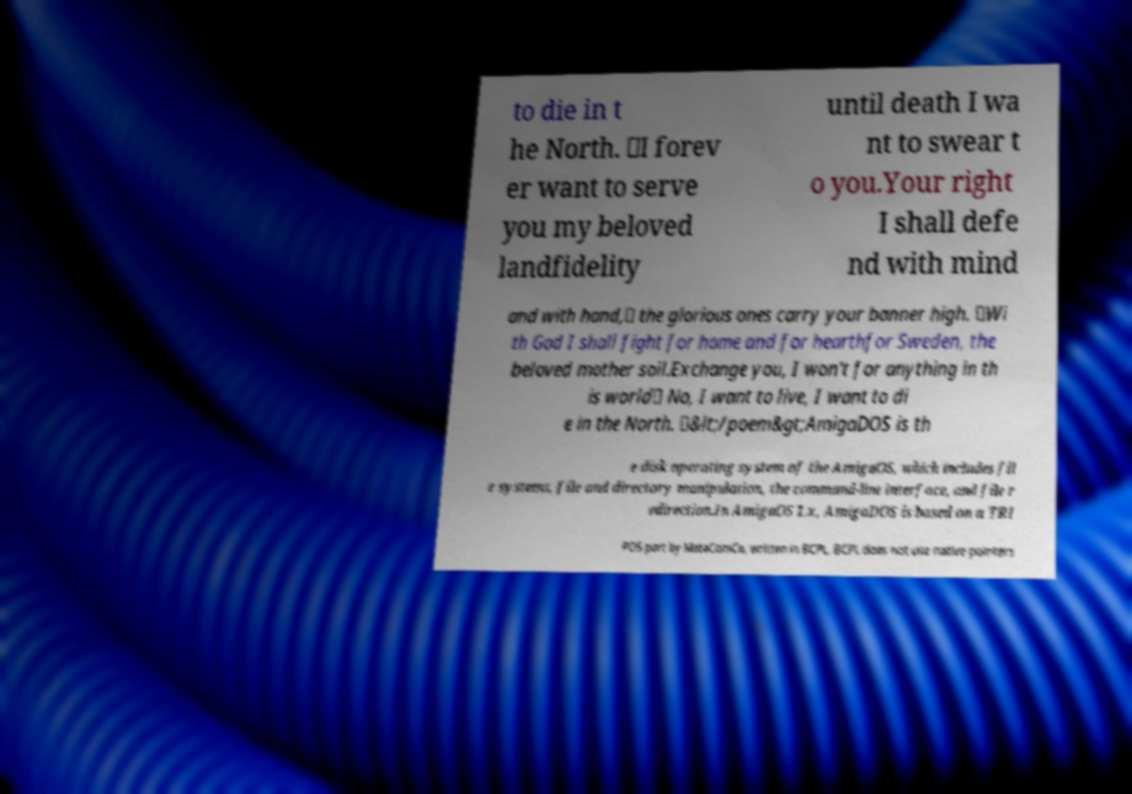There's text embedded in this image that I need extracted. Can you transcribe it verbatim? to die in t he North. 𝄇I forev er want to serve you my beloved landfidelity until death I wa nt to swear t o you.Your right I shall defe nd with mind and with hand,𝄆 the glorious ones carry your banner high. 𝄇Wi th God I shall fight for home and for hearthfor Sweden, the beloved mother soil.Exchange you, I won't for anything in th is world𝄆 No, I want to live, I want to di e in the North. 𝄇&lt;/poem&gt;AmigaDOS is th e disk operating system of the AmigaOS, which includes fil e systems, file and directory manipulation, the command-line interface, and file r edirection.In AmigaOS 1.x, AmigaDOS is based on a TRI POS port by MetaComCo, written in BCPL. BCPL does not use native pointers 